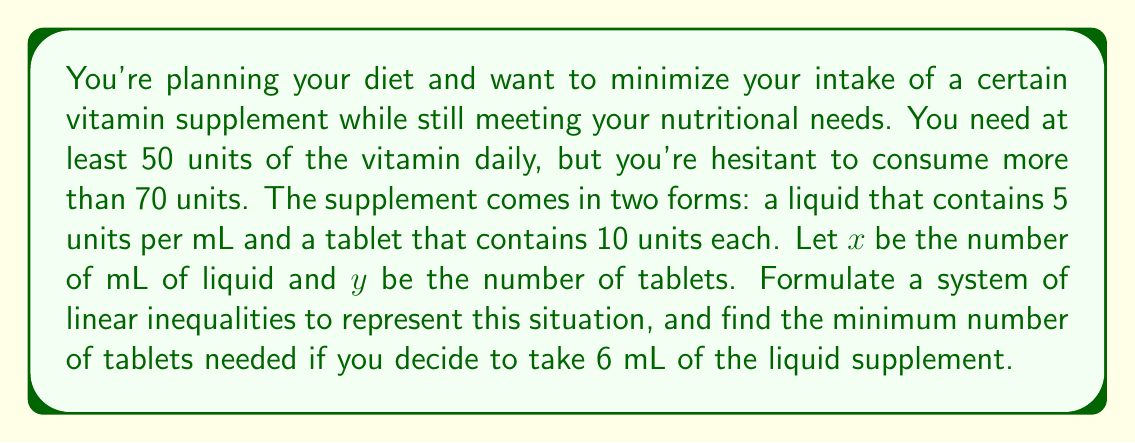Give your solution to this math problem. Let's approach this step-by-step:

1) First, we need to set up the inequalities:

   - The total units should be at least 50:
     $5x + 10y \geq 50$

   - The total units should not exceed 70:
     $5x + 10y \leq 70$

   - We can't have negative amounts of either form:
     $x \geq 0$ and $y \geq 0$

2) Now, we're told that we decide to take 6 mL of the liquid supplement. This means $x = 6$.

3) Substituting this into our inequalities:

   $5(6) + 10y \geq 50$
   $30 + 10y \geq 50$
   $10y \geq 20$
   $y \geq 2$

   $5(6) + 10y \leq 70$
   $30 + 10y \leq 70$
   $10y \leq 40$
   $y \leq 4$

4) Combining these results, we have:

   $2 \leq y \leq 4$

5) Since $y$ represents the number of tablets and we're asked to find the minimum number needed, we choose the lower bound.
Answer: 2 tablets 